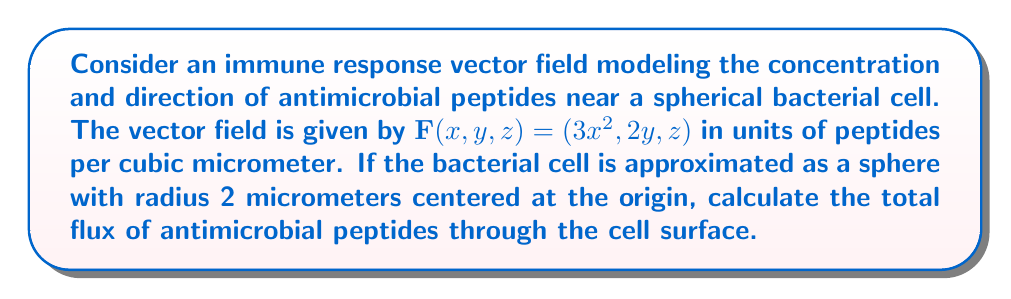Show me your answer to this math problem. To solve this problem, we'll use the divergence theorem, which relates the flux of a vector field through a closed surface to the divergence of the field within the volume enclosed by the surface.

1) The divergence theorem states:
   $$\iint_S \mathbf{F} \cdot \mathbf{n} \, dS = \iiint_V \nabla \cdot \mathbf{F} \, dV$$
   where $S$ is the surface, $V$ is the volume, and $\mathbf{n}$ is the outward unit normal vector.

2) First, we need to calculate the divergence of $\mathbf{F}$:
   $$\nabla \cdot \mathbf{F} = \frac{\partial}{\partial x}(3x^2) + \frac{\partial}{\partial y}(2y) + \frac{\partial}{\partial z}(z) = 6x + 2 + 1 = 6x + 3$$

3) Now, we need to integrate this over the volume of the sphere. In spherical coordinates:
   $$\iiint_V (6x + 3) \, dV = \int_0^{2\pi} \int_0^\pi \int_0^2 (6r\cos\theta + 3)r^2 \sin\theta \, dr \, d\theta \, d\phi$$

4) Let's solve this integral:
   $$\begin{align*}
   &= \int_0^{2\pi} \int_0^\pi \left[\frac{3r^3\cos\theta}{3} + r^3\right]_0^2 \sin\theta \, d\theta \, d\phi \\
   &= \int_0^{2\pi} \int_0^\pi (4\cos\theta + 8) \sin\theta \, d\theta \, d\phi \\
   &= 2\pi \int_0^\pi (4\cos\theta + 8) \sin\theta \, d\theta \\
   &= 2\pi \left[-4\cos\theta - 8\cos\theta\right]_0^\pi \\
   &= 2\pi (4 + 8 + 4 + 8) \\
   &= 48\pi
   \end{align*}$$

5) Therefore, the total flux through the surface of the bacterial cell is $48\pi$ peptides per square micrometer.
Answer: $48\pi$ peptides per square micrometer 